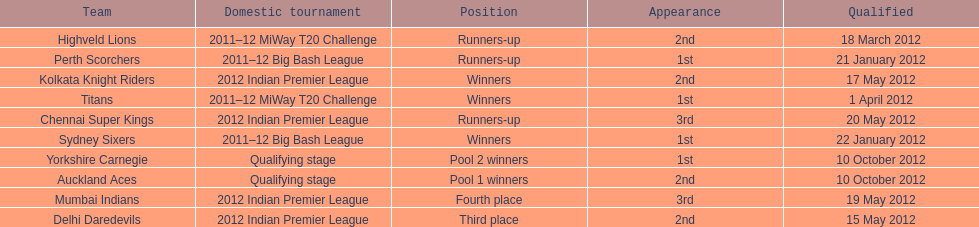Would you mind parsing the complete table? {'header': ['Team', 'Domestic tournament', 'Position', 'Appearance', 'Qualified'], 'rows': [['Highveld Lions', '2011–12 MiWay T20 Challenge', 'Runners-up', '2nd', '18 March 2012'], ['Perth Scorchers', '2011–12 Big Bash League', 'Runners-up', '1st', '21 January 2012'], ['Kolkata Knight Riders', '2012 Indian Premier League', 'Winners', '2nd', '17 May 2012'], ['Titans', '2011–12 MiWay T20 Challenge', 'Winners', '1st', '1 April 2012'], ['Chennai Super Kings', '2012 Indian Premier League', 'Runners-up', '3rd', '20 May 2012'], ['Sydney Sixers', '2011–12 Big Bash League', 'Winners', '1st', '22 January 2012'], ['Yorkshire Carnegie', 'Qualifying stage', 'Pool 2 winners', '1st', '10 October 2012'], ['Auckland Aces', 'Qualifying stage', 'Pool 1 winners', '2nd', '10 October 2012'], ['Mumbai Indians', '2012 Indian Premier League', 'Fourth place', '3rd', '19 May 2012'], ['Delhi Daredevils', '2012 Indian Premier League', 'Third place', '2nd', '15 May 2012']]} Which teams were the last to qualify? Auckland Aces, Yorkshire Carnegie. 